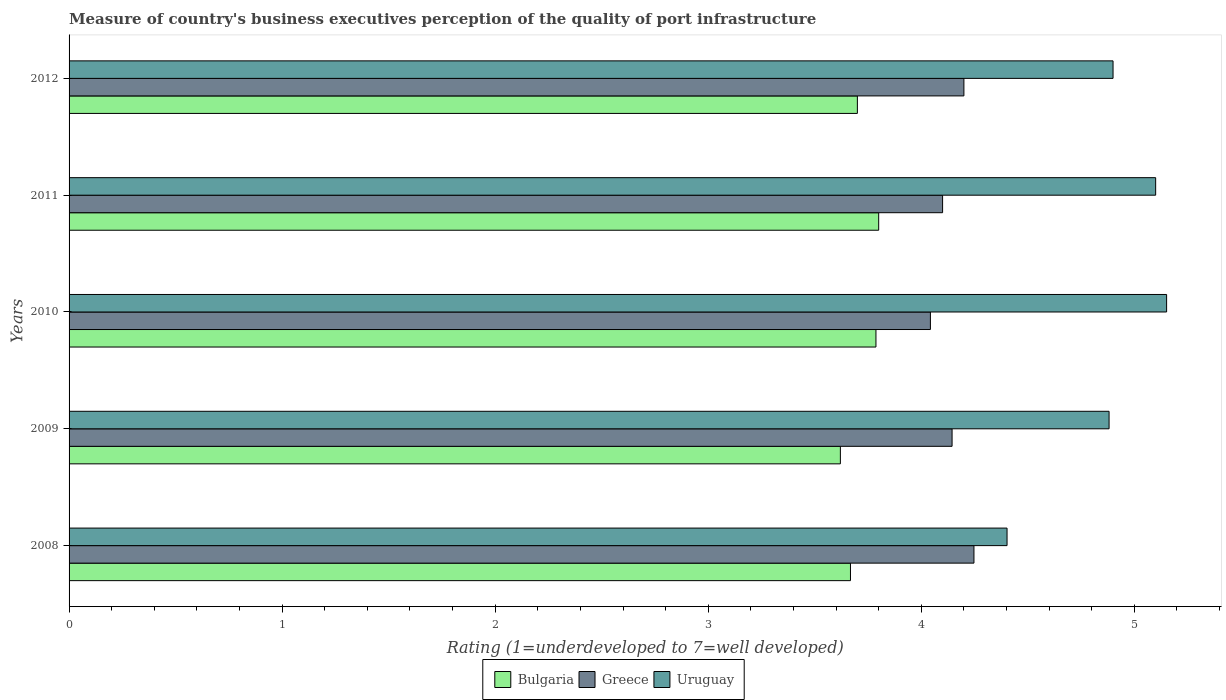How many different coloured bars are there?
Your answer should be compact. 3. How many groups of bars are there?
Your response must be concise. 5. Are the number of bars per tick equal to the number of legend labels?
Your answer should be very brief. Yes. How many bars are there on the 4th tick from the top?
Offer a very short reply. 3. What is the label of the 1st group of bars from the top?
Offer a very short reply. 2012. What is the ratings of the quality of port infrastructure in Greece in 2010?
Give a very brief answer. 4.04. Across all years, what is the maximum ratings of the quality of port infrastructure in Greece?
Provide a succinct answer. 4.25. Across all years, what is the minimum ratings of the quality of port infrastructure in Bulgaria?
Your response must be concise. 3.62. What is the total ratings of the quality of port infrastructure in Bulgaria in the graph?
Make the answer very short. 18.58. What is the difference between the ratings of the quality of port infrastructure in Bulgaria in 2008 and that in 2011?
Your answer should be compact. -0.13. What is the difference between the ratings of the quality of port infrastructure in Greece in 2011 and the ratings of the quality of port infrastructure in Uruguay in 2012?
Offer a very short reply. -0.8. What is the average ratings of the quality of port infrastructure in Greece per year?
Give a very brief answer. 4.15. In the year 2012, what is the difference between the ratings of the quality of port infrastructure in Uruguay and ratings of the quality of port infrastructure in Bulgaria?
Your answer should be compact. 1.2. What is the ratio of the ratings of the quality of port infrastructure in Greece in 2009 to that in 2012?
Offer a terse response. 0.99. Is the difference between the ratings of the quality of port infrastructure in Uruguay in 2008 and 2010 greater than the difference between the ratings of the quality of port infrastructure in Bulgaria in 2008 and 2010?
Your answer should be compact. No. What is the difference between the highest and the second highest ratings of the quality of port infrastructure in Uruguay?
Ensure brevity in your answer.  0.05. What is the difference between the highest and the lowest ratings of the quality of port infrastructure in Bulgaria?
Keep it short and to the point. 0.18. In how many years, is the ratings of the quality of port infrastructure in Bulgaria greater than the average ratings of the quality of port infrastructure in Bulgaria taken over all years?
Make the answer very short. 2. What does the 2nd bar from the top in 2010 represents?
Ensure brevity in your answer.  Greece. What does the 2nd bar from the bottom in 2011 represents?
Your answer should be very brief. Greece. Are all the bars in the graph horizontal?
Your response must be concise. Yes. What is the difference between two consecutive major ticks on the X-axis?
Make the answer very short. 1. Are the values on the major ticks of X-axis written in scientific E-notation?
Ensure brevity in your answer.  No. Does the graph contain any zero values?
Keep it short and to the point. No. Where does the legend appear in the graph?
Make the answer very short. Bottom center. How many legend labels are there?
Your answer should be compact. 3. How are the legend labels stacked?
Offer a terse response. Horizontal. What is the title of the graph?
Your answer should be very brief. Measure of country's business executives perception of the quality of port infrastructure. What is the label or title of the X-axis?
Keep it short and to the point. Rating (1=underdeveloped to 7=well developed). What is the label or title of the Y-axis?
Your answer should be compact. Years. What is the Rating (1=underdeveloped to 7=well developed) in Bulgaria in 2008?
Give a very brief answer. 3.67. What is the Rating (1=underdeveloped to 7=well developed) of Greece in 2008?
Make the answer very short. 4.25. What is the Rating (1=underdeveloped to 7=well developed) of Uruguay in 2008?
Your answer should be very brief. 4.4. What is the Rating (1=underdeveloped to 7=well developed) in Bulgaria in 2009?
Provide a succinct answer. 3.62. What is the Rating (1=underdeveloped to 7=well developed) of Greece in 2009?
Keep it short and to the point. 4.14. What is the Rating (1=underdeveloped to 7=well developed) of Uruguay in 2009?
Offer a terse response. 4.88. What is the Rating (1=underdeveloped to 7=well developed) in Bulgaria in 2010?
Make the answer very short. 3.79. What is the Rating (1=underdeveloped to 7=well developed) of Greece in 2010?
Your answer should be very brief. 4.04. What is the Rating (1=underdeveloped to 7=well developed) in Uruguay in 2010?
Offer a terse response. 5.15. What is the Rating (1=underdeveloped to 7=well developed) in Bulgaria in 2011?
Provide a short and direct response. 3.8. What is the Rating (1=underdeveloped to 7=well developed) of Greece in 2011?
Offer a very short reply. 4.1. What is the Rating (1=underdeveloped to 7=well developed) in Bulgaria in 2012?
Give a very brief answer. 3.7. What is the Rating (1=underdeveloped to 7=well developed) in Greece in 2012?
Your answer should be compact. 4.2. What is the Rating (1=underdeveloped to 7=well developed) in Uruguay in 2012?
Provide a short and direct response. 4.9. Across all years, what is the maximum Rating (1=underdeveloped to 7=well developed) in Bulgaria?
Provide a succinct answer. 3.8. Across all years, what is the maximum Rating (1=underdeveloped to 7=well developed) in Greece?
Make the answer very short. 4.25. Across all years, what is the maximum Rating (1=underdeveloped to 7=well developed) in Uruguay?
Keep it short and to the point. 5.15. Across all years, what is the minimum Rating (1=underdeveloped to 7=well developed) of Bulgaria?
Your answer should be very brief. 3.62. Across all years, what is the minimum Rating (1=underdeveloped to 7=well developed) in Greece?
Give a very brief answer. 4.04. Across all years, what is the minimum Rating (1=underdeveloped to 7=well developed) in Uruguay?
Make the answer very short. 4.4. What is the total Rating (1=underdeveloped to 7=well developed) of Bulgaria in the graph?
Keep it short and to the point. 18.57. What is the total Rating (1=underdeveloped to 7=well developed) in Greece in the graph?
Give a very brief answer. 20.73. What is the total Rating (1=underdeveloped to 7=well developed) in Uruguay in the graph?
Keep it short and to the point. 24.44. What is the difference between the Rating (1=underdeveloped to 7=well developed) of Bulgaria in 2008 and that in 2009?
Your response must be concise. 0.05. What is the difference between the Rating (1=underdeveloped to 7=well developed) in Greece in 2008 and that in 2009?
Ensure brevity in your answer.  0.1. What is the difference between the Rating (1=underdeveloped to 7=well developed) in Uruguay in 2008 and that in 2009?
Your answer should be very brief. -0.48. What is the difference between the Rating (1=underdeveloped to 7=well developed) in Bulgaria in 2008 and that in 2010?
Give a very brief answer. -0.12. What is the difference between the Rating (1=underdeveloped to 7=well developed) of Greece in 2008 and that in 2010?
Ensure brevity in your answer.  0.2. What is the difference between the Rating (1=underdeveloped to 7=well developed) of Uruguay in 2008 and that in 2010?
Your response must be concise. -0.75. What is the difference between the Rating (1=underdeveloped to 7=well developed) in Bulgaria in 2008 and that in 2011?
Give a very brief answer. -0.13. What is the difference between the Rating (1=underdeveloped to 7=well developed) of Greece in 2008 and that in 2011?
Provide a succinct answer. 0.15. What is the difference between the Rating (1=underdeveloped to 7=well developed) in Uruguay in 2008 and that in 2011?
Give a very brief answer. -0.7. What is the difference between the Rating (1=underdeveloped to 7=well developed) of Bulgaria in 2008 and that in 2012?
Your response must be concise. -0.03. What is the difference between the Rating (1=underdeveloped to 7=well developed) in Greece in 2008 and that in 2012?
Ensure brevity in your answer.  0.05. What is the difference between the Rating (1=underdeveloped to 7=well developed) in Uruguay in 2008 and that in 2012?
Offer a terse response. -0.5. What is the difference between the Rating (1=underdeveloped to 7=well developed) of Bulgaria in 2009 and that in 2010?
Your answer should be very brief. -0.17. What is the difference between the Rating (1=underdeveloped to 7=well developed) in Greece in 2009 and that in 2010?
Your response must be concise. 0.1. What is the difference between the Rating (1=underdeveloped to 7=well developed) of Uruguay in 2009 and that in 2010?
Your answer should be compact. -0.27. What is the difference between the Rating (1=underdeveloped to 7=well developed) in Bulgaria in 2009 and that in 2011?
Your response must be concise. -0.18. What is the difference between the Rating (1=underdeveloped to 7=well developed) of Greece in 2009 and that in 2011?
Your answer should be very brief. 0.04. What is the difference between the Rating (1=underdeveloped to 7=well developed) of Uruguay in 2009 and that in 2011?
Your response must be concise. -0.22. What is the difference between the Rating (1=underdeveloped to 7=well developed) of Bulgaria in 2009 and that in 2012?
Keep it short and to the point. -0.08. What is the difference between the Rating (1=underdeveloped to 7=well developed) in Greece in 2009 and that in 2012?
Your answer should be very brief. -0.06. What is the difference between the Rating (1=underdeveloped to 7=well developed) of Uruguay in 2009 and that in 2012?
Offer a terse response. -0.02. What is the difference between the Rating (1=underdeveloped to 7=well developed) in Bulgaria in 2010 and that in 2011?
Provide a succinct answer. -0.01. What is the difference between the Rating (1=underdeveloped to 7=well developed) in Greece in 2010 and that in 2011?
Make the answer very short. -0.06. What is the difference between the Rating (1=underdeveloped to 7=well developed) of Uruguay in 2010 and that in 2011?
Offer a very short reply. 0.05. What is the difference between the Rating (1=underdeveloped to 7=well developed) of Bulgaria in 2010 and that in 2012?
Provide a short and direct response. 0.09. What is the difference between the Rating (1=underdeveloped to 7=well developed) in Greece in 2010 and that in 2012?
Your answer should be very brief. -0.16. What is the difference between the Rating (1=underdeveloped to 7=well developed) in Uruguay in 2010 and that in 2012?
Your response must be concise. 0.25. What is the difference between the Rating (1=underdeveloped to 7=well developed) of Bulgaria in 2011 and that in 2012?
Provide a succinct answer. 0.1. What is the difference between the Rating (1=underdeveloped to 7=well developed) of Uruguay in 2011 and that in 2012?
Offer a terse response. 0.2. What is the difference between the Rating (1=underdeveloped to 7=well developed) in Bulgaria in 2008 and the Rating (1=underdeveloped to 7=well developed) in Greece in 2009?
Offer a very short reply. -0.48. What is the difference between the Rating (1=underdeveloped to 7=well developed) in Bulgaria in 2008 and the Rating (1=underdeveloped to 7=well developed) in Uruguay in 2009?
Provide a short and direct response. -1.21. What is the difference between the Rating (1=underdeveloped to 7=well developed) in Greece in 2008 and the Rating (1=underdeveloped to 7=well developed) in Uruguay in 2009?
Your answer should be compact. -0.63. What is the difference between the Rating (1=underdeveloped to 7=well developed) of Bulgaria in 2008 and the Rating (1=underdeveloped to 7=well developed) of Greece in 2010?
Ensure brevity in your answer.  -0.38. What is the difference between the Rating (1=underdeveloped to 7=well developed) in Bulgaria in 2008 and the Rating (1=underdeveloped to 7=well developed) in Uruguay in 2010?
Ensure brevity in your answer.  -1.48. What is the difference between the Rating (1=underdeveloped to 7=well developed) in Greece in 2008 and the Rating (1=underdeveloped to 7=well developed) in Uruguay in 2010?
Ensure brevity in your answer.  -0.9. What is the difference between the Rating (1=underdeveloped to 7=well developed) of Bulgaria in 2008 and the Rating (1=underdeveloped to 7=well developed) of Greece in 2011?
Make the answer very short. -0.43. What is the difference between the Rating (1=underdeveloped to 7=well developed) of Bulgaria in 2008 and the Rating (1=underdeveloped to 7=well developed) of Uruguay in 2011?
Provide a short and direct response. -1.43. What is the difference between the Rating (1=underdeveloped to 7=well developed) of Greece in 2008 and the Rating (1=underdeveloped to 7=well developed) of Uruguay in 2011?
Provide a succinct answer. -0.85. What is the difference between the Rating (1=underdeveloped to 7=well developed) of Bulgaria in 2008 and the Rating (1=underdeveloped to 7=well developed) of Greece in 2012?
Your response must be concise. -0.53. What is the difference between the Rating (1=underdeveloped to 7=well developed) in Bulgaria in 2008 and the Rating (1=underdeveloped to 7=well developed) in Uruguay in 2012?
Keep it short and to the point. -1.23. What is the difference between the Rating (1=underdeveloped to 7=well developed) in Greece in 2008 and the Rating (1=underdeveloped to 7=well developed) in Uruguay in 2012?
Offer a terse response. -0.65. What is the difference between the Rating (1=underdeveloped to 7=well developed) in Bulgaria in 2009 and the Rating (1=underdeveloped to 7=well developed) in Greece in 2010?
Your answer should be very brief. -0.42. What is the difference between the Rating (1=underdeveloped to 7=well developed) in Bulgaria in 2009 and the Rating (1=underdeveloped to 7=well developed) in Uruguay in 2010?
Your answer should be very brief. -1.53. What is the difference between the Rating (1=underdeveloped to 7=well developed) in Greece in 2009 and the Rating (1=underdeveloped to 7=well developed) in Uruguay in 2010?
Provide a short and direct response. -1.01. What is the difference between the Rating (1=underdeveloped to 7=well developed) of Bulgaria in 2009 and the Rating (1=underdeveloped to 7=well developed) of Greece in 2011?
Provide a short and direct response. -0.48. What is the difference between the Rating (1=underdeveloped to 7=well developed) in Bulgaria in 2009 and the Rating (1=underdeveloped to 7=well developed) in Uruguay in 2011?
Give a very brief answer. -1.48. What is the difference between the Rating (1=underdeveloped to 7=well developed) of Greece in 2009 and the Rating (1=underdeveloped to 7=well developed) of Uruguay in 2011?
Ensure brevity in your answer.  -0.96. What is the difference between the Rating (1=underdeveloped to 7=well developed) in Bulgaria in 2009 and the Rating (1=underdeveloped to 7=well developed) in Greece in 2012?
Offer a very short reply. -0.58. What is the difference between the Rating (1=underdeveloped to 7=well developed) in Bulgaria in 2009 and the Rating (1=underdeveloped to 7=well developed) in Uruguay in 2012?
Your response must be concise. -1.28. What is the difference between the Rating (1=underdeveloped to 7=well developed) of Greece in 2009 and the Rating (1=underdeveloped to 7=well developed) of Uruguay in 2012?
Your answer should be very brief. -0.76. What is the difference between the Rating (1=underdeveloped to 7=well developed) of Bulgaria in 2010 and the Rating (1=underdeveloped to 7=well developed) of Greece in 2011?
Give a very brief answer. -0.31. What is the difference between the Rating (1=underdeveloped to 7=well developed) of Bulgaria in 2010 and the Rating (1=underdeveloped to 7=well developed) of Uruguay in 2011?
Ensure brevity in your answer.  -1.31. What is the difference between the Rating (1=underdeveloped to 7=well developed) of Greece in 2010 and the Rating (1=underdeveloped to 7=well developed) of Uruguay in 2011?
Your answer should be compact. -1.06. What is the difference between the Rating (1=underdeveloped to 7=well developed) in Bulgaria in 2010 and the Rating (1=underdeveloped to 7=well developed) in Greece in 2012?
Provide a short and direct response. -0.41. What is the difference between the Rating (1=underdeveloped to 7=well developed) in Bulgaria in 2010 and the Rating (1=underdeveloped to 7=well developed) in Uruguay in 2012?
Provide a short and direct response. -1.11. What is the difference between the Rating (1=underdeveloped to 7=well developed) in Greece in 2010 and the Rating (1=underdeveloped to 7=well developed) in Uruguay in 2012?
Keep it short and to the point. -0.86. What is the difference between the Rating (1=underdeveloped to 7=well developed) of Bulgaria in 2011 and the Rating (1=underdeveloped to 7=well developed) of Greece in 2012?
Your response must be concise. -0.4. What is the average Rating (1=underdeveloped to 7=well developed) of Bulgaria per year?
Your answer should be compact. 3.71. What is the average Rating (1=underdeveloped to 7=well developed) in Greece per year?
Ensure brevity in your answer.  4.15. What is the average Rating (1=underdeveloped to 7=well developed) in Uruguay per year?
Offer a very short reply. 4.89. In the year 2008, what is the difference between the Rating (1=underdeveloped to 7=well developed) in Bulgaria and Rating (1=underdeveloped to 7=well developed) in Greece?
Keep it short and to the point. -0.58. In the year 2008, what is the difference between the Rating (1=underdeveloped to 7=well developed) of Bulgaria and Rating (1=underdeveloped to 7=well developed) of Uruguay?
Your answer should be very brief. -0.73. In the year 2008, what is the difference between the Rating (1=underdeveloped to 7=well developed) of Greece and Rating (1=underdeveloped to 7=well developed) of Uruguay?
Provide a short and direct response. -0.16. In the year 2009, what is the difference between the Rating (1=underdeveloped to 7=well developed) in Bulgaria and Rating (1=underdeveloped to 7=well developed) in Greece?
Make the answer very short. -0.52. In the year 2009, what is the difference between the Rating (1=underdeveloped to 7=well developed) of Bulgaria and Rating (1=underdeveloped to 7=well developed) of Uruguay?
Offer a terse response. -1.26. In the year 2009, what is the difference between the Rating (1=underdeveloped to 7=well developed) of Greece and Rating (1=underdeveloped to 7=well developed) of Uruguay?
Ensure brevity in your answer.  -0.74. In the year 2010, what is the difference between the Rating (1=underdeveloped to 7=well developed) in Bulgaria and Rating (1=underdeveloped to 7=well developed) in Greece?
Make the answer very short. -0.26. In the year 2010, what is the difference between the Rating (1=underdeveloped to 7=well developed) in Bulgaria and Rating (1=underdeveloped to 7=well developed) in Uruguay?
Your answer should be compact. -1.36. In the year 2010, what is the difference between the Rating (1=underdeveloped to 7=well developed) of Greece and Rating (1=underdeveloped to 7=well developed) of Uruguay?
Your answer should be compact. -1.11. In the year 2011, what is the difference between the Rating (1=underdeveloped to 7=well developed) in Bulgaria and Rating (1=underdeveloped to 7=well developed) in Uruguay?
Offer a very short reply. -1.3. In the year 2012, what is the difference between the Rating (1=underdeveloped to 7=well developed) in Bulgaria and Rating (1=underdeveloped to 7=well developed) in Greece?
Give a very brief answer. -0.5. In the year 2012, what is the difference between the Rating (1=underdeveloped to 7=well developed) of Greece and Rating (1=underdeveloped to 7=well developed) of Uruguay?
Make the answer very short. -0.7. What is the ratio of the Rating (1=underdeveloped to 7=well developed) of Bulgaria in 2008 to that in 2009?
Provide a succinct answer. 1.01. What is the ratio of the Rating (1=underdeveloped to 7=well developed) in Greece in 2008 to that in 2009?
Give a very brief answer. 1.02. What is the ratio of the Rating (1=underdeveloped to 7=well developed) in Uruguay in 2008 to that in 2009?
Keep it short and to the point. 0.9. What is the ratio of the Rating (1=underdeveloped to 7=well developed) in Bulgaria in 2008 to that in 2010?
Provide a succinct answer. 0.97. What is the ratio of the Rating (1=underdeveloped to 7=well developed) in Greece in 2008 to that in 2010?
Provide a short and direct response. 1.05. What is the ratio of the Rating (1=underdeveloped to 7=well developed) in Uruguay in 2008 to that in 2010?
Give a very brief answer. 0.85. What is the ratio of the Rating (1=underdeveloped to 7=well developed) of Bulgaria in 2008 to that in 2011?
Offer a terse response. 0.97. What is the ratio of the Rating (1=underdeveloped to 7=well developed) in Greece in 2008 to that in 2011?
Your answer should be compact. 1.04. What is the ratio of the Rating (1=underdeveloped to 7=well developed) in Uruguay in 2008 to that in 2011?
Your response must be concise. 0.86. What is the ratio of the Rating (1=underdeveloped to 7=well developed) of Bulgaria in 2008 to that in 2012?
Offer a very short reply. 0.99. What is the ratio of the Rating (1=underdeveloped to 7=well developed) of Greece in 2008 to that in 2012?
Offer a terse response. 1.01. What is the ratio of the Rating (1=underdeveloped to 7=well developed) in Uruguay in 2008 to that in 2012?
Your answer should be compact. 0.9. What is the ratio of the Rating (1=underdeveloped to 7=well developed) in Bulgaria in 2009 to that in 2010?
Provide a short and direct response. 0.96. What is the ratio of the Rating (1=underdeveloped to 7=well developed) of Greece in 2009 to that in 2010?
Offer a very short reply. 1.03. What is the ratio of the Rating (1=underdeveloped to 7=well developed) of Uruguay in 2009 to that in 2010?
Keep it short and to the point. 0.95. What is the ratio of the Rating (1=underdeveloped to 7=well developed) in Bulgaria in 2009 to that in 2011?
Keep it short and to the point. 0.95. What is the ratio of the Rating (1=underdeveloped to 7=well developed) in Greece in 2009 to that in 2011?
Your response must be concise. 1.01. What is the ratio of the Rating (1=underdeveloped to 7=well developed) in Uruguay in 2009 to that in 2011?
Provide a short and direct response. 0.96. What is the ratio of the Rating (1=underdeveloped to 7=well developed) of Bulgaria in 2009 to that in 2012?
Offer a very short reply. 0.98. What is the ratio of the Rating (1=underdeveloped to 7=well developed) in Greece in 2009 to that in 2012?
Keep it short and to the point. 0.99. What is the ratio of the Rating (1=underdeveloped to 7=well developed) in Uruguay in 2009 to that in 2012?
Offer a terse response. 1. What is the ratio of the Rating (1=underdeveloped to 7=well developed) of Bulgaria in 2010 to that in 2012?
Offer a very short reply. 1.02. What is the ratio of the Rating (1=underdeveloped to 7=well developed) in Greece in 2010 to that in 2012?
Your response must be concise. 0.96. What is the ratio of the Rating (1=underdeveloped to 7=well developed) in Uruguay in 2010 to that in 2012?
Offer a terse response. 1.05. What is the ratio of the Rating (1=underdeveloped to 7=well developed) of Bulgaria in 2011 to that in 2012?
Offer a very short reply. 1.03. What is the ratio of the Rating (1=underdeveloped to 7=well developed) of Greece in 2011 to that in 2012?
Make the answer very short. 0.98. What is the ratio of the Rating (1=underdeveloped to 7=well developed) of Uruguay in 2011 to that in 2012?
Provide a succinct answer. 1.04. What is the difference between the highest and the second highest Rating (1=underdeveloped to 7=well developed) in Bulgaria?
Your response must be concise. 0.01. What is the difference between the highest and the second highest Rating (1=underdeveloped to 7=well developed) of Greece?
Make the answer very short. 0.05. What is the difference between the highest and the second highest Rating (1=underdeveloped to 7=well developed) of Uruguay?
Keep it short and to the point. 0.05. What is the difference between the highest and the lowest Rating (1=underdeveloped to 7=well developed) of Bulgaria?
Your response must be concise. 0.18. What is the difference between the highest and the lowest Rating (1=underdeveloped to 7=well developed) of Greece?
Keep it short and to the point. 0.2. What is the difference between the highest and the lowest Rating (1=underdeveloped to 7=well developed) in Uruguay?
Your response must be concise. 0.75. 